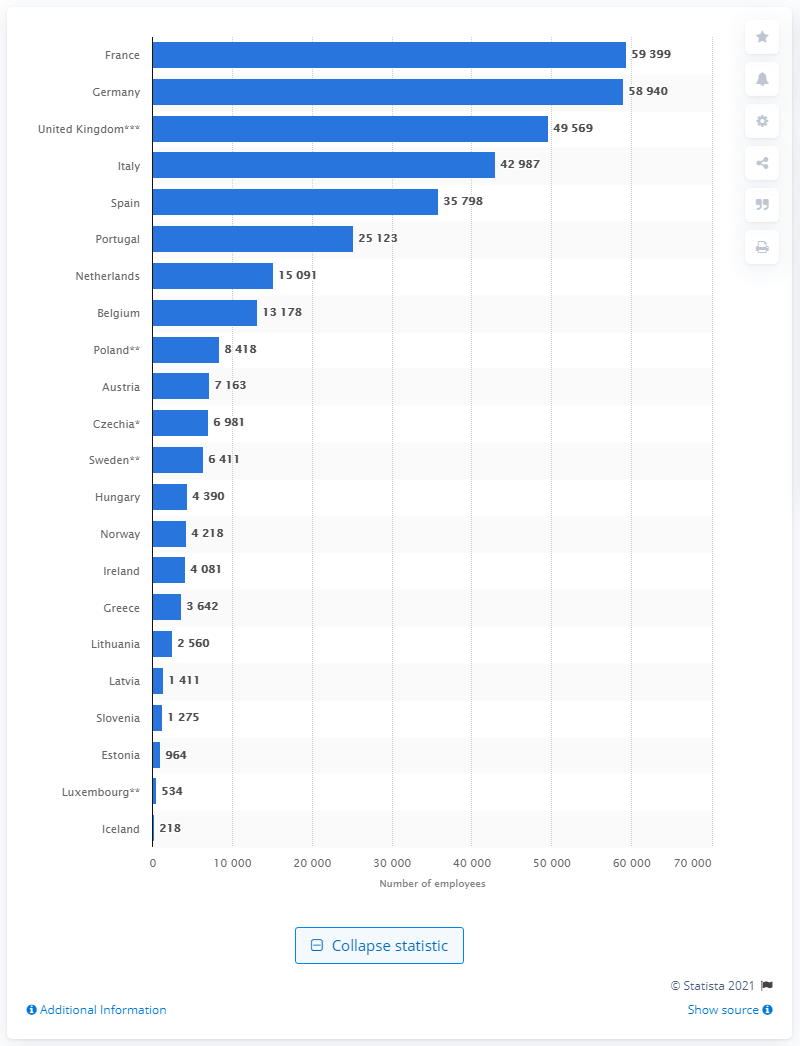Identify some key points in this picture. In 2018, Germany had 59,399 general practitioners, according to the latest available data. France has the highest number of GPs in Europe. 